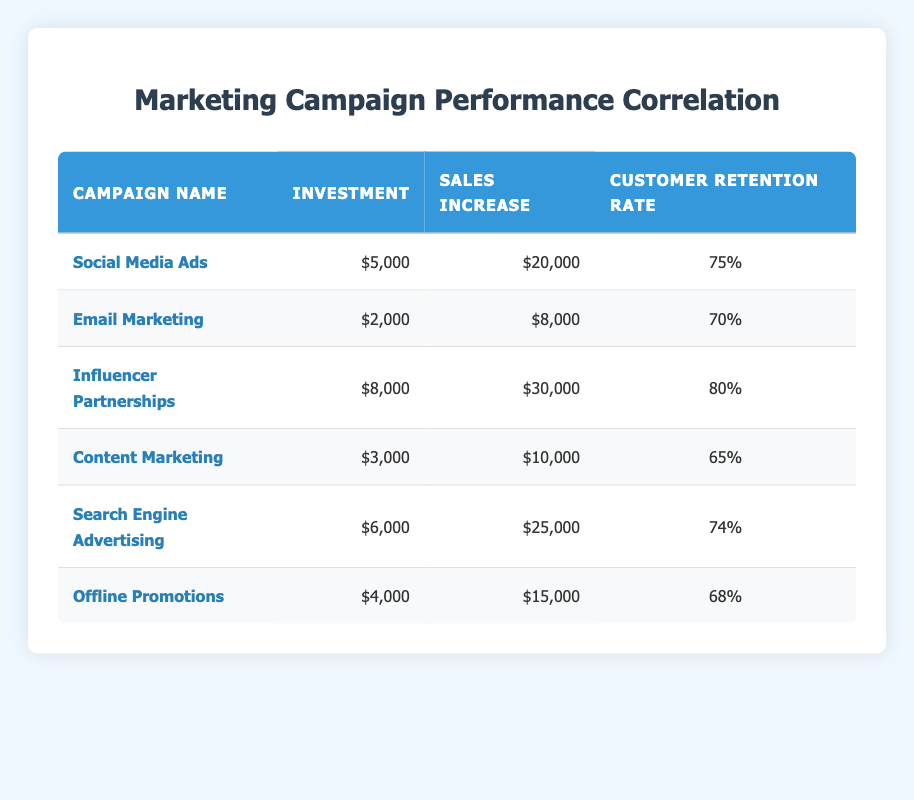What is the investment amount for the "Influencer Partnerships" campaign? The investment amount for the "Influencer Partnerships" campaign is located in the corresponding row under the Investment column. It shows an amount of 8000.
Answer: 8000 Which marketing campaign has the highest customer retention rate? By comparing the Customer Retention Rate column, "Influencer Partnerships" has the highest value at 80.
Answer: Influencer Partnerships What is the total sales increase from all campaigns combined? To find the total sales increase, sum all values in the Sales Increase column: 20000 + 8000 + 30000 + 10000 + 25000 + 15000 = 108000.
Answer: 108000 Is the investment amount for "Email Marketing" less than $3000? Checking the investment value for "Email Marketing," which is 2000, shows that it is indeed less than 3000.
Answer: Yes What is the average customer retention rate across all campaigns? Calculate the average by summing all customer retention rates (75 + 70 + 80 + 65 + 74 + 68 = 432) and dividing by the number of campaigns (6): 432 / 6 = 72.
Answer: 72 What is the difference between the sales increase of "Social Media Ads" and "Content Marketing"? Find the sales increase for both campaigns: "Social Media Ads" is 20000, and "Content Marketing" is 10000. Then calculate the difference: 20000 - 10000 = 10000.
Answer: 10000 Does "Search Engine Advertising" have a higher investment than "Offline Promotions"? Comparing the investment amounts: "Search Engine Advertising" is 6000, and "Offline Promotions" is 4000. Since 6000 is greater than 4000, the statement is true.
Answer: Yes Which marketing campaign provides the best return on investment (ROI) based on sales increase to investment ratio? Calculate ROI for each campaign by dividing sales increase by investment: Social Media Ads (20000/5000 = 4), Email Marketing (8000/2000 = 4), Influencer Partnerships (30000/8000 = 3.75), Content Marketing (10000/3000 = 3.33), Search Engine Advertising (25000/6000 ≈ 4.17), and Offline Promotions (15000/4000 = 3.75). The highest ROI is from Social Media Ads and Email Marketing, both at 4.
Answer: Social Media Ads and Email Marketing How many marketing campaigns have a customer retention rate of 75% or higher? Identify campaigns with a retention rate of 75% or higher: "Social Media Ads" (75), "Influencer Partnerships" (80) and "Search Engine Advertising" (74). Hence, 3 campaigns meet this criterion.
Answer: 2 